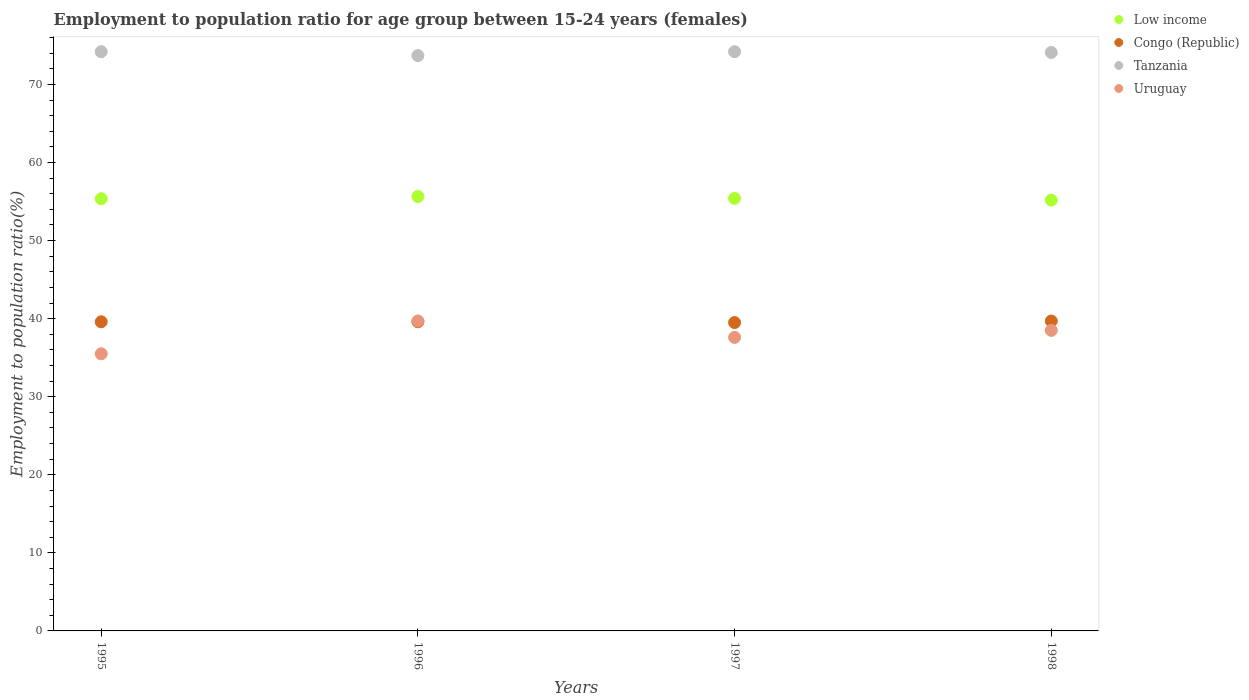How many different coloured dotlines are there?
Provide a short and direct response. 4. What is the employment to population ratio in Uruguay in 1996?
Ensure brevity in your answer.  39.7. Across all years, what is the maximum employment to population ratio in Tanzania?
Offer a terse response. 74.2. Across all years, what is the minimum employment to population ratio in Tanzania?
Keep it short and to the point. 73.7. In which year was the employment to population ratio in Congo (Republic) maximum?
Ensure brevity in your answer.  1998. What is the total employment to population ratio in Uruguay in the graph?
Offer a terse response. 151.3. What is the difference between the employment to population ratio in Uruguay in 1997 and that in 1998?
Your answer should be compact. -0.9. What is the difference between the employment to population ratio in Congo (Republic) in 1997 and the employment to population ratio in Tanzania in 1996?
Provide a succinct answer. -34.2. What is the average employment to population ratio in Congo (Republic) per year?
Provide a succinct answer. 39.6. In the year 1997, what is the difference between the employment to population ratio in Tanzania and employment to population ratio in Congo (Republic)?
Your response must be concise. 34.7. In how many years, is the employment to population ratio in Uruguay greater than 2 %?
Ensure brevity in your answer.  4. What is the ratio of the employment to population ratio in Uruguay in 1996 to that in 1998?
Your answer should be compact. 1.03. What is the difference between the highest and the second highest employment to population ratio in Uruguay?
Give a very brief answer. 1.2. What is the difference between the highest and the lowest employment to population ratio in Congo (Republic)?
Your response must be concise. 0.2. Is it the case that in every year, the sum of the employment to population ratio in Tanzania and employment to population ratio in Congo (Republic)  is greater than the employment to population ratio in Uruguay?
Your answer should be very brief. Yes. Does the employment to population ratio in Congo (Republic) monotonically increase over the years?
Offer a terse response. No. How many dotlines are there?
Offer a terse response. 4. How many years are there in the graph?
Offer a terse response. 4. What is the difference between two consecutive major ticks on the Y-axis?
Give a very brief answer. 10. Where does the legend appear in the graph?
Provide a succinct answer. Top right. How many legend labels are there?
Keep it short and to the point. 4. What is the title of the graph?
Provide a succinct answer. Employment to population ratio for age group between 15-24 years (females). Does "Faeroe Islands" appear as one of the legend labels in the graph?
Your answer should be very brief. No. What is the label or title of the Y-axis?
Offer a terse response. Employment to population ratio(%). What is the Employment to population ratio(%) of Low income in 1995?
Ensure brevity in your answer.  55.36. What is the Employment to population ratio(%) in Congo (Republic) in 1995?
Provide a succinct answer. 39.6. What is the Employment to population ratio(%) of Tanzania in 1995?
Your answer should be very brief. 74.2. What is the Employment to population ratio(%) in Uruguay in 1995?
Provide a short and direct response. 35.5. What is the Employment to population ratio(%) of Low income in 1996?
Your answer should be compact. 55.65. What is the Employment to population ratio(%) in Congo (Republic) in 1996?
Your response must be concise. 39.6. What is the Employment to population ratio(%) in Tanzania in 1996?
Offer a very short reply. 73.7. What is the Employment to population ratio(%) in Uruguay in 1996?
Keep it short and to the point. 39.7. What is the Employment to population ratio(%) of Low income in 1997?
Provide a short and direct response. 55.41. What is the Employment to population ratio(%) in Congo (Republic) in 1997?
Offer a terse response. 39.5. What is the Employment to population ratio(%) of Tanzania in 1997?
Your answer should be compact. 74.2. What is the Employment to population ratio(%) in Uruguay in 1997?
Make the answer very short. 37.6. What is the Employment to population ratio(%) in Low income in 1998?
Your answer should be compact. 55.18. What is the Employment to population ratio(%) in Congo (Republic) in 1998?
Your response must be concise. 39.7. What is the Employment to population ratio(%) of Tanzania in 1998?
Provide a short and direct response. 74.1. What is the Employment to population ratio(%) of Uruguay in 1998?
Ensure brevity in your answer.  38.5. Across all years, what is the maximum Employment to population ratio(%) in Low income?
Your response must be concise. 55.65. Across all years, what is the maximum Employment to population ratio(%) in Congo (Republic)?
Keep it short and to the point. 39.7. Across all years, what is the maximum Employment to population ratio(%) of Tanzania?
Make the answer very short. 74.2. Across all years, what is the maximum Employment to population ratio(%) of Uruguay?
Your answer should be compact. 39.7. Across all years, what is the minimum Employment to population ratio(%) in Low income?
Your answer should be very brief. 55.18. Across all years, what is the minimum Employment to population ratio(%) of Congo (Republic)?
Offer a terse response. 39.5. Across all years, what is the minimum Employment to population ratio(%) in Tanzania?
Your answer should be very brief. 73.7. Across all years, what is the minimum Employment to population ratio(%) of Uruguay?
Offer a terse response. 35.5. What is the total Employment to population ratio(%) of Low income in the graph?
Provide a short and direct response. 221.6. What is the total Employment to population ratio(%) in Congo (Republic) in the graph?
Offer a terse response. 158.4. What is the total Employment to population ratio(%) of Tanzania in the graph?
Your response must be concise. 296.2. What is the total Employment to population ratio(%) of Uruguay in the graph?
Your answer should be compact. 151.3. What is the difference between the Employment to population ratio(%) of Low income in 1995 and that in 1996?
Offer a very short reply. -0.29. What is the difference between the Employment to population ratio(%) of Uruguay in 1995 and that in 1996?
Offer a terse response. -4.2. What is the difference between the Employment to population ratio(%) in Low income in 1995 and that in 1997?
Your answer should be compact. -0.04. What is the difference between the Employment to population ratio(%) of Congo (Republic) in 1995 and that in 1997?
Offer a very short reply. 0.1. What is the difference between the Employment to population ratio(%) in Uruguay in 1995 and that in 1997?
Make the answer very short. -2.1. What is the difference between the Employment to population ratio(%) in Low income in 1995 and that in 1998?
Make the answer very short. 0.18. What is the difference between the Employment to population ratio(%) of Congo (Republic) in 1995 and that in 1998?
Ensure brevity in your answer.  -0.1. What is the difference between the Employment to population ratio(%) of Uruguay in 1995 and that in 1998?
Your answer should be very brief. -3. What is the difference between the Employment to population ratio(%) of Low income in 1996 and that in 1997?
Ensure brevity in your answer.  0.24. What is the difference between the Employment to population ratio(%) in Low income in 1996 and that in 1998?
Offer a terse response. 0.47. What is the difference between the Employment to population ratio(%) in Congo (Republic) in 1996 and that in 1998?
Offer a very short reply. -0.1. What is the difference between the Employment to population ratio(%) of Uruguay in 1996 and that in 1998?
Your response must be concise. 1.2. What is the difference between the Employment to population ratio(%) in Low income in 1997 and that in 1998?
Make the answer very short. 0.22. What is the difference between the Employment to population ratio(%) of Low income in 1995 and the Employment to population ratio(%) of Congo (Republic) in 1996?
Provide a succinct answer. 15.76. What is the difference between the Employment to population ratio(%) of Low income in 1995 and the Employment to population ratio(%) of Tanzania in 1996?
Offer a very short reply. -18.34. What is the difference between the Employment to population ratio(%) of Low income in 1995 and the Employment to population ratio(%) of Uruguay in 1996?
Keep it short and to the point. 15.66. What is the difference between the Employment to population ratio(%) in Congo (Republic) in 1995 and the Employment to population ratio(%) in Tanzania in 1996?
Offer a very short reply. -34.1. What is the difference between the Employment to population ratio(%) in Congo (Republic) in 1995 and the Employment to population ratio(%) in Uruguay in 1996?
Keep it short and to the point. -0.1. What is the difference between the Employment to population ratio(%) of Tanzania in 1995 and the Employment to population ratio(%) of Uruguay in 1996?
Your response must be concise. 34.5. What is the difference between the Employment to population ratio(%) in Low income in 1995 and the Employment to population ratio(%) in Congo (Republic) in 1997?
Make the answer very short. 15.86. What is the difference between the Employment to population ratio(%) in Low income in 1995 and the Employment to population ratio(%) in Tanzania in 1997?
Provide a succinct answer. -18.84. What is the difference between the Employment to population ratio(%) of Low income in 1995 and the Employment to population ratio(%) of Uruguay in 1997?
Offer a very short reply. 17.76. What is the difference between the Employment to population ratio(%) in Congo (Republic) in 1995 and the Employment to population ratio(%) in Tanzania in 1997?
Offer a terse response. -34.6. What is the difference between the Employment to population ratio(%) of Congo (Republic) in 1995 and the Employment to population ratio(%) of Uruguay in 1997?
Give a very brief answer. 2. What is the difference between the Employment to population ratio(%) of Tanzania in 1995 and the Employment to population ratio(%) of Uruguay in 1997?
Offer a terse response. 36.6. What is the difference between the Employment to population ratio(%) in Low income in 1995 and the Employment to population ratio(%) in Congo (Republic) in 1998?
Keep it short and to the point. 15.66. What is the difference between the Employment to population ratio(%) of Low income in 1995 and the Employment to population ratio(%) of Tanzania in 1998?
Your answer should be compact. -18.74. What is the difference between the Employment to population ratio(%) of Low income in 1995 and the Employment to population ratio(%) of Uruguay in 1998?
Make the answer very short. 16.86. What is the difference between the Employment to population ratio(%) of Congo (Republic) in 1995 and the Employment to population ratio(%) of Tanzania in 1998?
Your answer should be compact. -34.5. What is the difference between the Employment to population ratio(%) of Congo (Republic) in 1995 and the Employment to population ratio(%) of Uruguay in 1998?
Provide a short and direct response. 1.1. What is the difference between the Employment to population ratio(%) in Tanzania in 1995 and the Employment to population ratio(%) in Uruguay in 1998?
Give a very brief answer. 35.7. What is the difference between the Employment to population ratio(%) of Low income in 1996 and the Employment to population ratio(%) of Congo (Republic) in 1997?
Ensure brevity in your answer.  16.15. What is the difference between the Employment to population ratio(%) in Low income in 1996 and the Employment to population ratio(%) in Tanzania in 1997?
Your answer should be very brief. -18.55. What is the difference between the Employment to population ratio(%) in Low income in 1996 and the Employment to population ratio(%) in Uruguay in 1997?
Your response must be concise. 18.05. What is the difference between the Employment to population ratio(%) in Congo (Republic) in 1996 and the Employment to population ratio(%) in Tanzania in 1997?
Keep it short and to the point. -34.6. What is the difference between the Employment to population ratio(%) in Congo (Republic) in 1996 and the Employment to population ratio(%) in Uruguay in 1997?
Offer a terse response. 2. What is the difference between the Employment to population ratio(%) in Tanzania in 1996 and the Employment to population ratio(%) in Uruguay in 1997?
Offer a terse response. 36.1. What is the difference between the Employment to population ratio(%) of Low income in 1996 and the Employment to population ratio(%) of Congo (Republic) in 1998?
Your response must be concise. 15.95. What is the difference between the Employment to population ratio(%) of Low income in 1996 and the Employment to population ratio(%) of Tanzania in 1998?
Provide a succinct answer. -18.45. What is the difference between the Employment to population ratio(%) of Low income in 1996 and the Employment to population ratio(%) of Uruguay in 1998?
Your answer should be compact. 17.15. What is the difference between the Employment to population ratio(%) in Congo (Republic) in 1996 and the Employment to population ratio(%) in Tanzania in 1998?
Keep it short and to the point. -34.5. What is the difference between the Employment to population ratio(%) of Congo (Republic) in 1996 and the Employment to population ratio(%) of Uruguay in 1998?
Keep it short and to the point. 1.1. What is the difference between the Employment to population ratio(%) in Tanzania in 1996 and the Employment to population ratio(%) in Uruguay in 1998?
Your answer should be compact. 35.2. What is the difference between the Employment to population ratio(%) in Low income in 1997 and the Employment to population ratio(%) in Congo (Republic) in 1998?
Your answer should be compact. 15.71. What is the difference between the Employment to population ratio(%) of Low income in 1997 and the Employment to population ratio(%) of Tanzania in 1998?
Offer a terse response. -18.69. What is the difference between the Employment to population ratio(%) of Low income in 1997 and the Employment to population ratio(%) of Uruguay in 1998?
Offer a terse response. 16.91. What is the difference between the Employment to population ratio(%) in Congo (Republic) in 1997 and the Employment to population ratio(%) in Tanzania in 1998?
Ensure brevity in your answer.  -34.6. What is the difference between the Employment to population ratio(%) of Congo (Republic) in 1997 and the Employment to population ratio(%) of Uruguay in 1998?
Give a very brief answer. 1. What is the difference between the Employment to population ratio(%) of Tanzania in 1997 and the Employment to population ratio(%) of Uruguay in 1998?
Offer a very short reply. 35.7. What is the average Employment to population ratio(%) of Low income per year?
Offer a terse response. 55.4. What is the average Employment to population ratio(%) of Congo (Republic) per year?
Ensure brevity in your answer.  39.6. What is the average Employment to population ratio(%) in Tanzania per year?
Your answer should be compact. 74.05. What is the average Employment to population ratio(%) of Uruguay per year?
Give a very brief answer. 37.83. In the year 1995, what is the difference between the Employment to population ratio(%) of Low income and Employment to population ratio(%) of Congo (Republic)?
Ensure brevity in your answer.  15.76. In the year 1995, what is the difference between the Employment to population ratio(%) in Low income and Employment to population ratio(%) in Tanzania?
Ensure brevity in your answer.  -18.84. In the year 1995, what is the difference between the Employment to population ratio(%) of Low income and Employment to population ratio(%) of Uruguay?
Keep it short and to the point. 19.86. In the year 1995, what is the difference between the Employment to population ratio(%) in Congo (Republic) and Employment to population ratio(%) in Tanzania?
Provide a short and direct response. -34.6. In the year 1995, what is the difference between the Employment to population ratio(%) of Congo (Republic) and Employment to population ratio(%) of Uruguay?
Offer a terse response. 4.1. In the year 1995, what is the difference between the Employment to population ratio(%) in Tanzania and Employment to population ratio(%) in Uruguay?
Ensure brevity in your answer.  38.7. In the year 1996, what is the difference between the Employment to population ratio(%) in Low income and Employment to population ratio(%) in Congo (Republic)?
Offer a very short reply. 16.05. In the year 1996, what is the difference between the Employment to population ratio(%) in Low income and Employment to population ratio(%) in Tanzania?
Your answer should be compact. -18.05. In the year 1996, what is the difference between the Employment to population ratio(%) of Low income and Employment to population ratio(%) of Uruguay?
Keep it short and to the point. 15.95. In the year 1996, what is the difference between the Employment to population ratio(%) of Congo (Republic) and Employment to population ratio(%) of Tanzania?
Offer a terse response. -34.1. In the year 1997, what is the difference between the Employment to population ratio(%) of Low income and Employment to population ratio(%) of Congo (Republic)?
Keep it short and to the point. 15.91. In the year 1997, what is the difference between the Employment to population ratio(%) in Low income and Employment to population ratio(%) in Tanzania?
Keep it short and to the point. -18.79. In the year 1997, what is the difference between the Employment to population ratio(%) in Low income and Employment to population ratio(%) in Uruguay?
Provide a short and direct response. 17.81. In the year 1997, what is the difference between the Employment to population ratio(%) of Congo (Republic) and Employment to population ratio(%) of Tanzania?
Offer a very short reply. -34.7. In the year 1997, what is the difference between the Employment to population ratio(%) in Tanzania and Employment to population ratio(%) in Uruguay?
Your answer should be compact. 36.6. In the year 1998, what is the difference between the Employment to population ratio(%) of Low income and Employment to population ratio(%) of Congo (Republic)?
Ensure brevity in your answer.  15.48. In the year 1998, what is the difference between the Employment to population ratio(%) in Low income and Employment to population ratio(%) in Tanzania?
Your answer should be very brief. -18.92. In the year 1998, what is the difference between the Employment to population ratio(%) in Low income and Employment to population ratio(%) in Uruguay?
Ensure brevity in your answer.  16.68. In the year 1998, what is the difference between the Employment to population ratio(%) of Congo (Republic) and Employment to population ratio(%) of Tanzania?
Ensure brevity in your answer.  -34.4. In the year 1998, what is the difference between the Employment to population ratio(%) in Congo (Republic) and Employment to population ratio(%) in Uruguay?
Offer a terse response. 1.2. In the year 1998, what is the difference between the Employment to population ratio(%) of Tanzania and Employment to population ratio(%) of Uruguay?
Your answer should be compact. 35.6. What is the ratio of the Employment to population ratio(%) of Tanzania in 1995 to that in 1996?
Your answer should be very brief. 1.01. What is the ratio of the Employment to population ratio(%) of Uruguay in 1995 to that in 1996?
Keep it short and to the point. 0.89. What is the ratio of the Employment to population ratio(%) in Uruguay in 1995 to that in 1997?
Your answer should be very brief. 0.94. What is the ratio of the Employment to population ratio(%) in Low income in 1995 to that in 1998?
Ensure brevity in your answer.  1. What is the ratio of the Employment to population ratio(%) of Congo (Republic) in 1995 to that in 1998?
Keep it short and to the point. 1. What is the ratio of the Employment to population ratio(%) in Tanzania in 1995 to that in 1998?
Provide a succinct answer. 1. What is the ratio of the Employment to population ratio(%) of Uruguay in 1995 to that in 1998?
Your answer should be compact. 0.92. What is the ratio of the Employment to population ratio(%) in Tanzania in 1996 to that in 1997?
Your response must be concise. 0.99. What is the ratio of the Employment to population ratio(%) of Uruguay in 1996 to that in 1997?
Keep it short and to the point. 1.06. What is the ratio of the Employment to population ratio(%) of Low income in 1996 to that in 1998?
Keep it short and to the point. 1.01. What is the ratio of the Employment to population ratio(%) in Tanzania in 1996 to that in 1998?
Your answer should be very brief. 0.99. What is the ratio of the Employment to population ratio(%) in Uruguay in 1996 to that in 1998?
Keep it short and to the point. 1.03. What is the ratio of the Employment to population ratio(%) in Low income in 1997 to that in 1998?
Give a very brief answer. 1. What is the ratio of the Employment to population ratio(%) of Congo (Republic) in 1997 to that in 1998?
Make the answer very short. 0.99. What is the ratio of the Employment to population ratio(%) of Uruguay in 1997 to that in 1998?
Your answer should be compact. 0.98. What is the difference between the highest and the second highest Employment to population ratio(%) in Low income?
Your answer should be very brief. 0.24. What is the difference between the highest and the second highest Employment to population ratio(%) in Congo (Republic)?
Provide a succinct answer. 0.1. What is the difference between the highest and the second highest Employment to population ratio(%) in Uruguay?
Keep it short and to the point. 1.2. What is the difference between the highest and the lowest Employment to population ratio(%) of Low income?
Your response must be concise. 0.47. What is the difference between the highest and the lowest Employment to population ratio(%) in Congo (Republic)?
Provide a succinct answer. 0.2. 